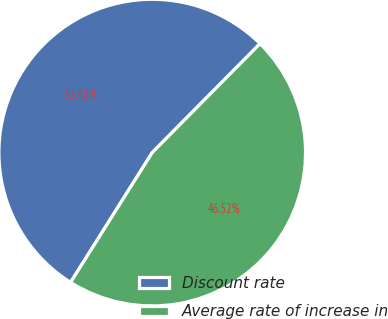Convert chart to OTSL. <chart><loc_0><loc_0><loc_500><loc_500><pie_chart><fcel>Discount rate<fcel>Average rate of increase in<nl><fcel>53.48%<fcel>46.52%<nl></chart> 